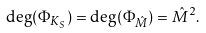<formula> <loc_0><loc_0><loc_500><loc_500>\deg ( \Phi _ { K _ { S } } ) = \deg ( \Phi _ { \hat { M } } ) = \hat { M } ^ { 2 } .</formula> 